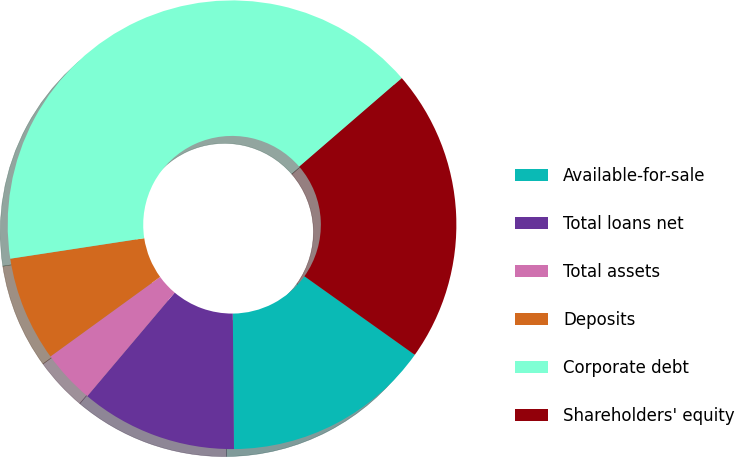Convert chart. <chart><loc_0><loc_0><loc_500><loc_500><pie_chart><fcel>Available-for-sale<fcel>Total loans net<fcel>Total assets<fcel>Deposits<fcel>Corporate debt<fcel>Shareholders' equity<nl><fcel>15.02%<fcel>11.3%<fcel>3.85%<fcel>7.57%<fcel>41.08%<fcel>21.18%<nl></chart> 